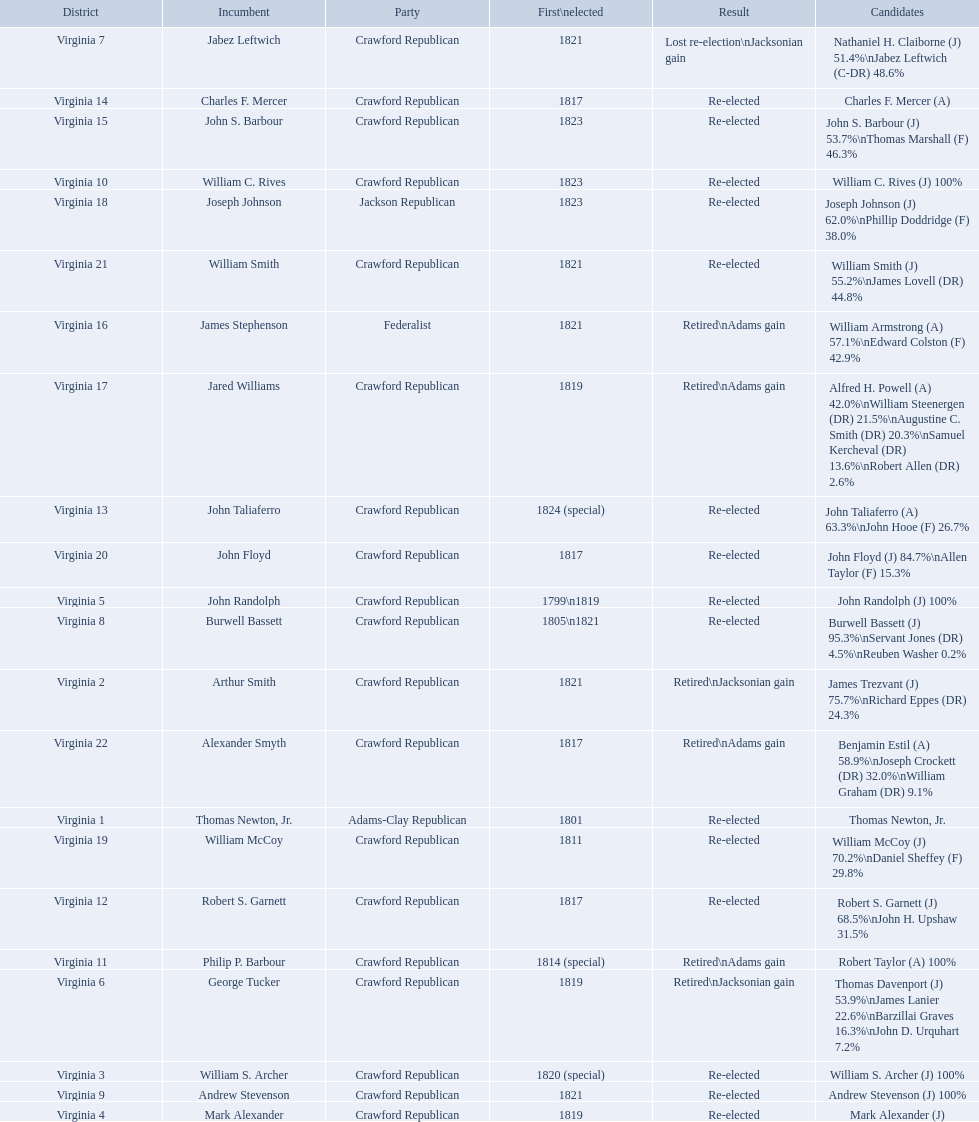Which incumbents belonged to the crawford republican party? Arthur Smith, William S. Archer, Mark Alexander, John Randolph, George Tucker, Jabez Leftwich, Burwell Bassett, Andrew Stevenson, William C. Rives, Philip P. Barbour, Robert S. Garnett, John Taliaferro, Charles F. Mercer, John S. Barbour, Jared Williams, William McCoy, John Floyd, William Smith, Alexander Smyth. Which of these incumbents were first elected in 1821? Arthur Smith, Jabez Leftwich, Andrew Stevenson, William Smith. Which of these incumbents have a last name of smith? Arthur Smith, William Smith. Which of these two were not re-elected? Arthur Smith. 